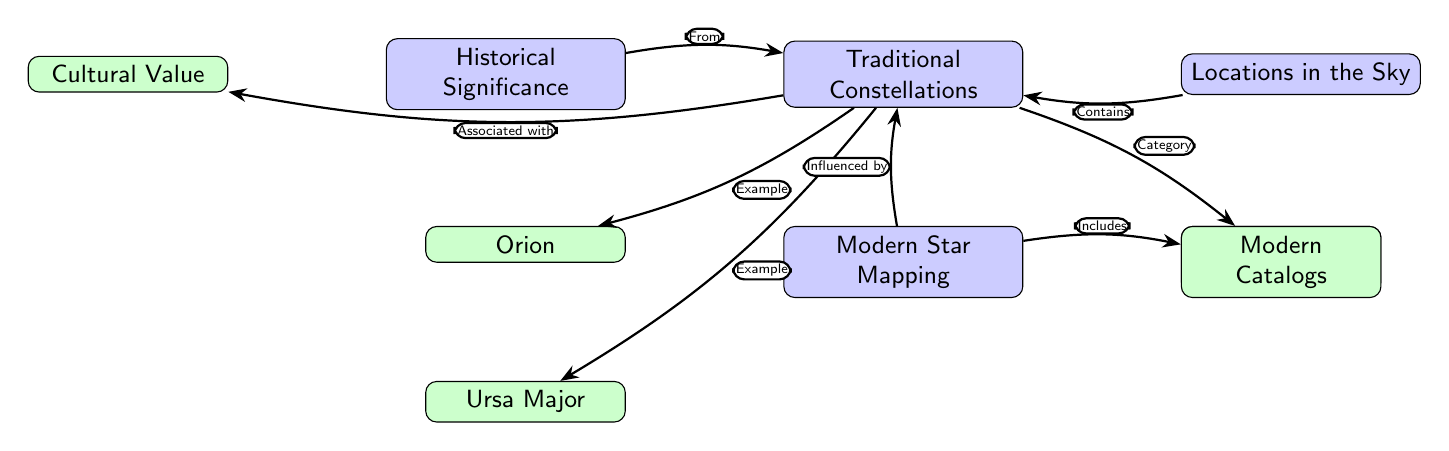What are the traditional constellations mentioned? The diagram lists "Orion" and "Ursa Major" as examples of traditional constellations.
Answer: Orion, Ursa Major How many main nodes are in the diagram? The diagram features four main nodes: Traditional Constellations, Modern Star Mapping, Historical Significance, and Locations in the Sky.
Answer: 4 What does Modern Star Mapping include? The diagram indicates that Modern Star Mapping includes "Modern Catalogs".
Answer: Modern Catalogs Which constellation is categorized with Zodiacal Constellations? The diagram directly connects Zodiacal Constellations to Traditional Constellations, showing they fall under the same category.
Answer: Zodiacal Constellations What cultural aspect is associated with Traditional Constellations? The edge connects Traditional Constellations to Cultural Value, implying their significant cultural importance.
Answer: Cultural Value What is influenced by Traditional Constellations? The diagram shows that Modern Star Mapping is influenced by Traditional Constellations.
Answer: Modern Star Mapping What is located in the sky according to the diagram? The diagram states that Locations in the Sky contains Traditional Constellations, reinforcing their positional aspect.
Answer: Traditional Constellations How many edges are connected to the node Traditional Constellations? There are four edges emanating from the Traditional Constellations node in the diagram: two to modern star mapping and one each to cultural value and historical significance.
Answer: 4 Which historical aspect is derived from Traditional Constellations? The diagram notes that Historical Significance derives from Traditional Constellations, illustrating their impact on history.
Answer: From Traditional Constellations 